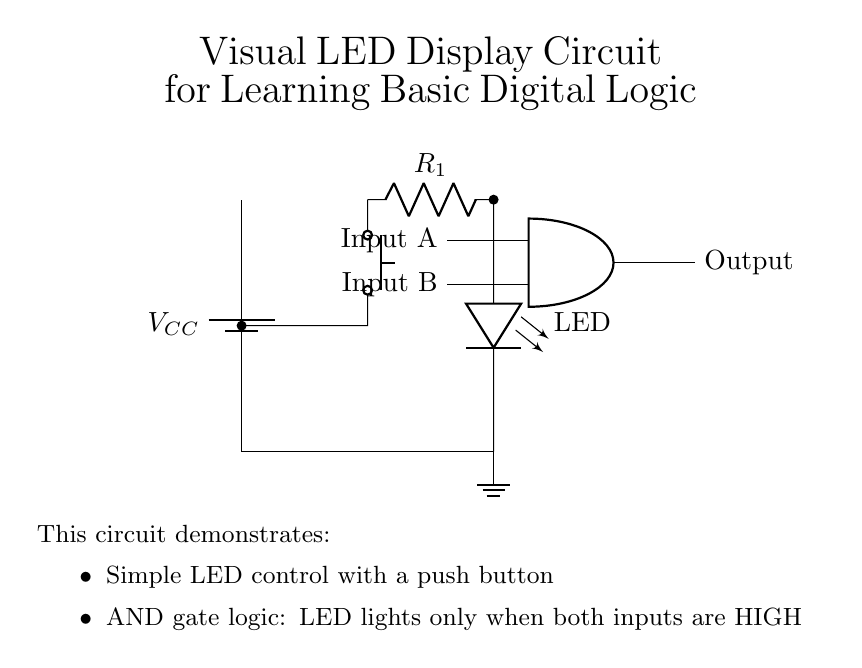What is the function of the push button? The push button serves as a manual input control, allowing the user to create a connection that can enable or disable the LED under certain conditions in the circuit.
Answer: Manual input What role does the resistor play in this circuit? The resistor limits the current flowing to the LED, preventing it from drawing too much current and potentially burning out.
Answer: Current limit How is the LED powered in this circuit? The LED receives power through the connection from the voltage supply via the resistor, which ensures it operates safely without exceeding its current rating.
Answer: Through the resistor What type of logic gate is present in this circuit? The circuit contains an AND gate, which outputs a high signal only when both of its inputs are high, thereby controlling the LED depending on the state of both inputs A and B.
Answer: AND gate What must be true for the LED to light up? For the LED to light up, both input signals (A and B) must be high, which is necessary for the AND gate to output a high signal that activates the LED.
Answer: Both inputs high What kind of grounding is used in this circuit? The circuit utilizes a direct ground connection, indicated at the bottom of the LED where the circuit completes to the ground node.
Answer: Direct ground What is the voltage supply in the circuit? The voltage supply is represented by the battery symbol, typically denoted as VCC, and is essential for powering the circuit components.
Answer: VCC 